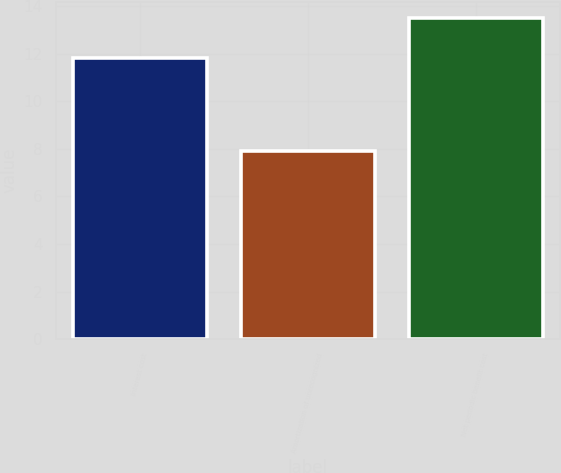<chart> <loc_0><loc_0><loc_500><loc_500><bar_chart><fcel>Interest cost<fcel>Amortization of unrecognized<fcel>Net periodic benefit cost<nl><fcel>11.8<fcel>7.9<fcel>13.5<nl></chart> 